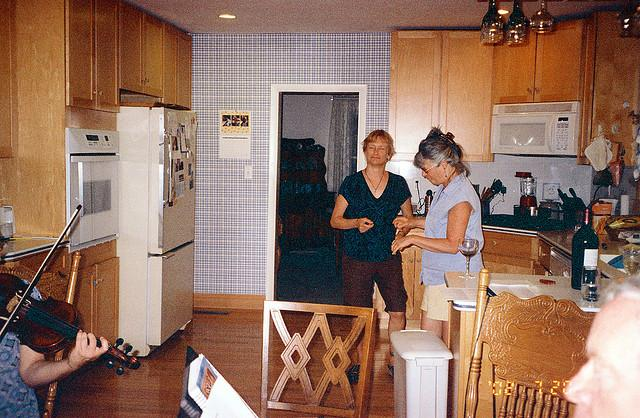What instrument is the person on the left playing?

Choices:
A) banjo
B) harp
C) violin
D) guitar violin 